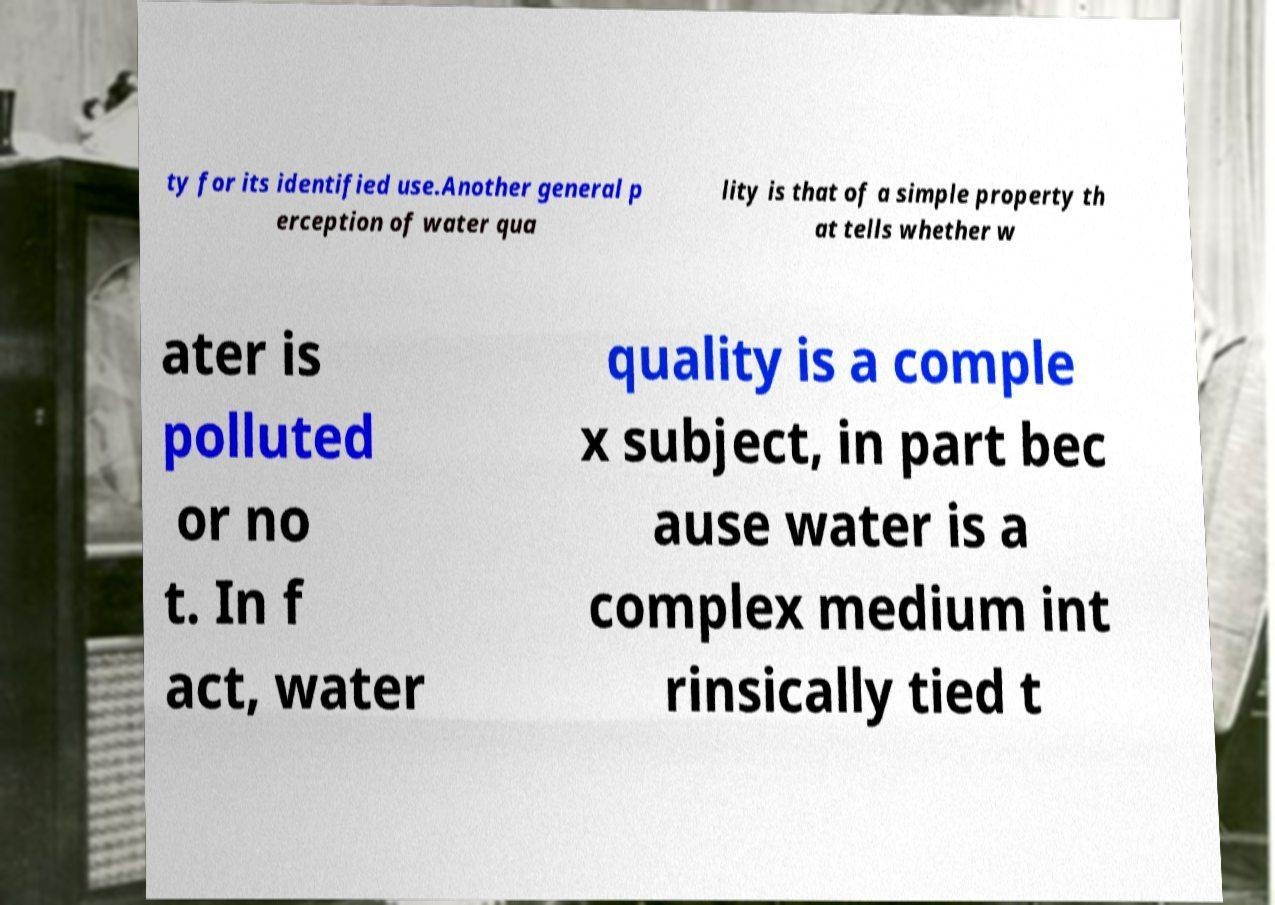I need the written content from this picture converted into text. Can you do that? ty for its identified use.Another general p erception of water qua lity is that of a simple property th at tells whether w ater is polluted or no t. In f act, water quality is a comple x subject, in part bec ause water is a complex medium int rinsically tied t 